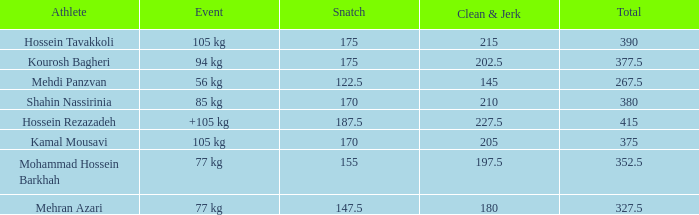What is the total that had an event of +105 kg and clean & jerk less than 227.5? 0.0. 